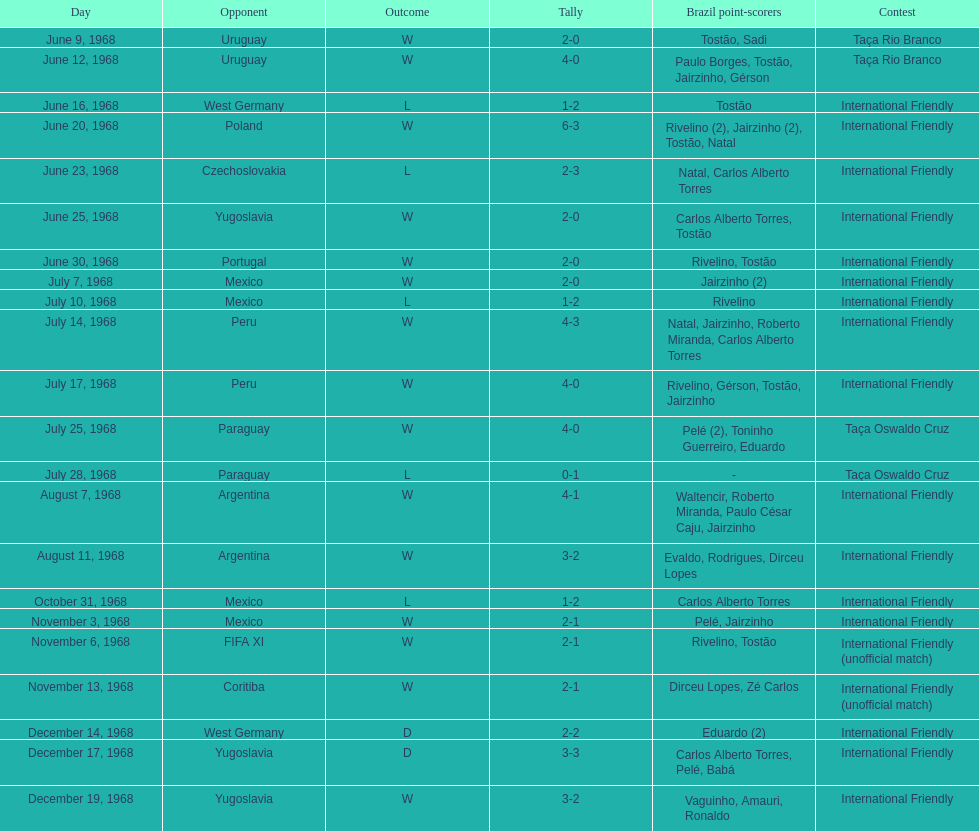Who played brazil previous to the game on june 30th? Yugoslavia. 